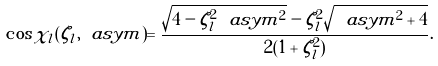Convert formula to latex. <formula><loc_0><loc_0><loc_500><loc_500>\cos \chi _ { l } ( \zeta _ { l } , \ a s y m ) = \frac { \sqrt { 4 - \zeta _ { l } ^ { 2 } \ a s y m ^ { 2 } } - \zeta _ { l } ^ { 2 } \sqrt { \ a s y m ^ { 2 } + 4 } } { 2 ( 1 + \zeta _ { l } ^ { 2 } ) } .</formula> 